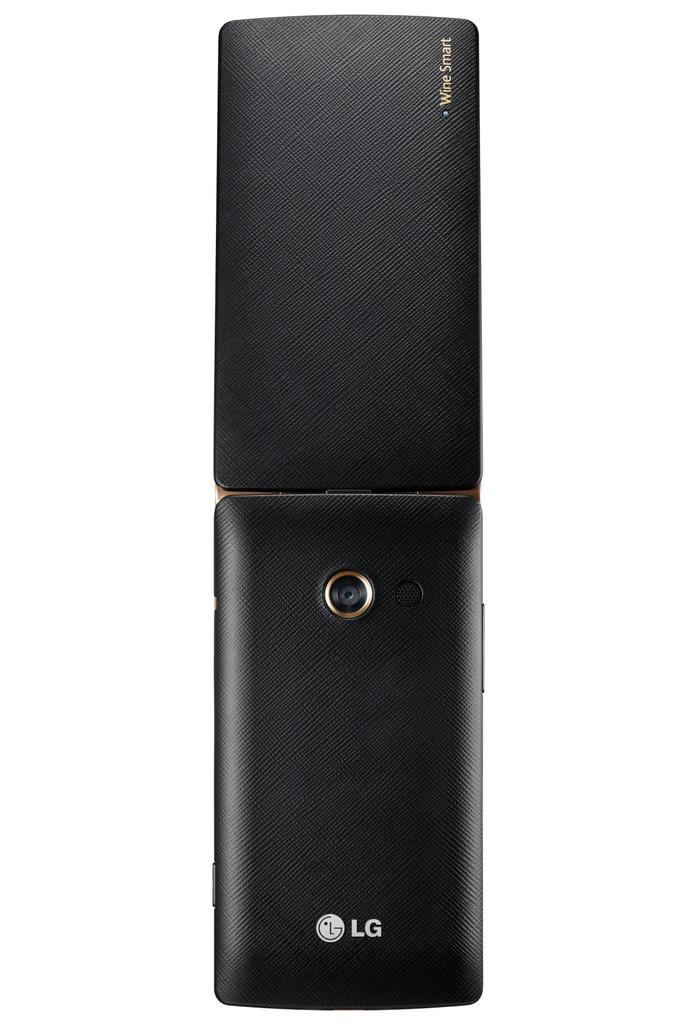<image>
Write a terse but informative summary of the picture. An LG flip phone seen from the back side. 